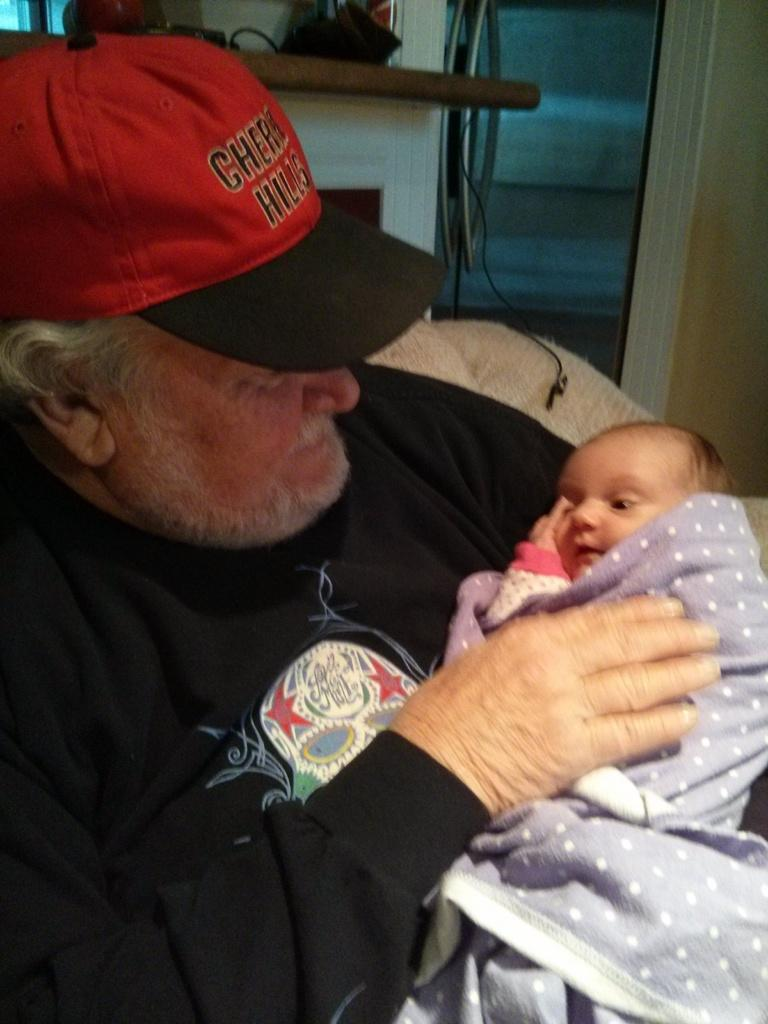<image>
Describe the image concisely. An older gentleman wearing a red, Cherry Hill hat is holding an infant in a purple blanket. 